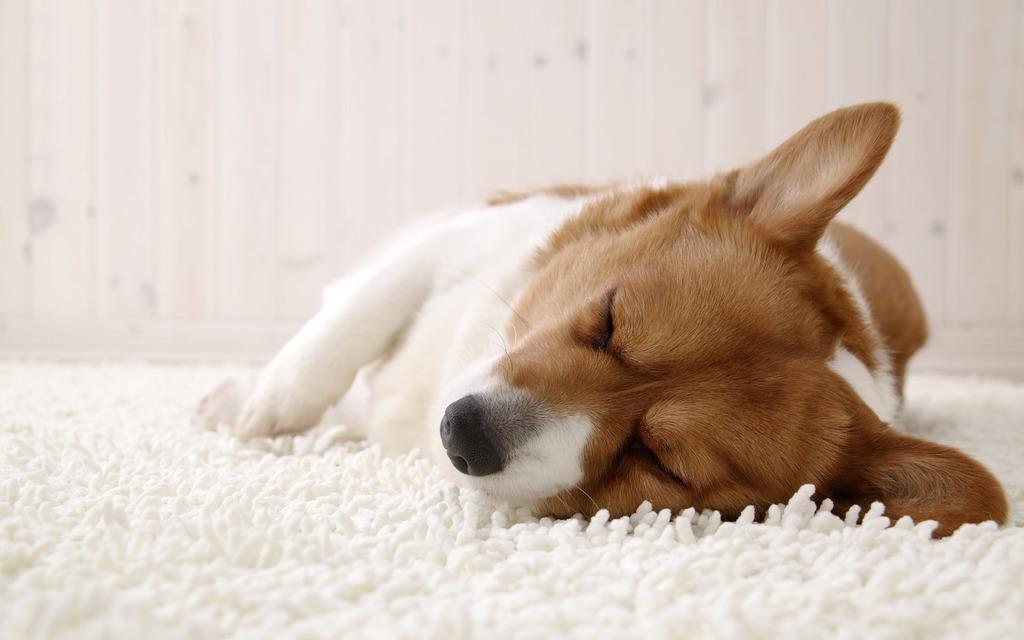In one or two sentences, can you explain what this image depicts? In this image there is a dog sleeping, there is a white color floor mat, at the background of the image there is a wall. 